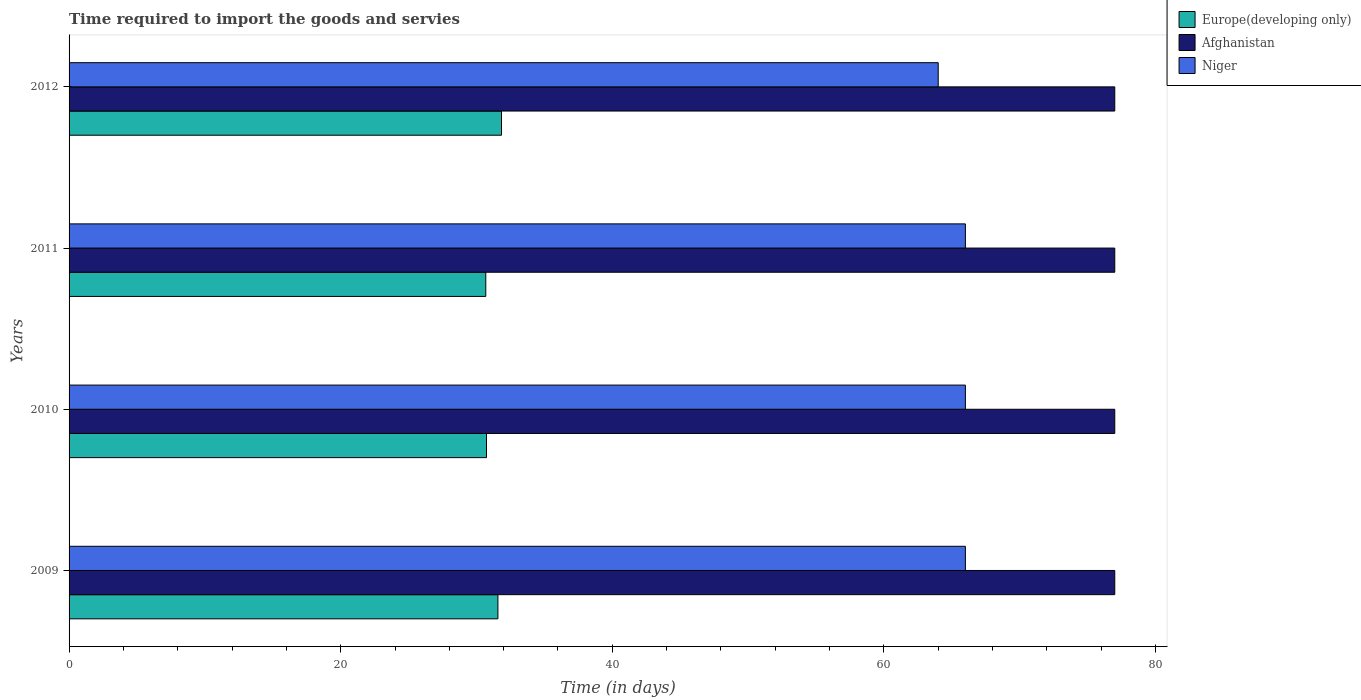How many different coloured bars are there?
Your response must be concise. 3. How many groups of bars are there?
Offer a terse response. 4. Are the number of bars per tick equal to the number of legend labels?
Provide a succinct answer. Yes. Are the number of bars on each tick of the Y-axis equal?
Provide a succinct answer. Yes. How many bars are there on the 4th tick from the top?
Your answer should be compact. 3. What is the label of the 3rd group of bars from the top?
Offer a very short reply. 2010. What is the number of days required to import the goods and services in Europe(developing only) in 2010?
Provide a short and direct response. 30.74. Across all years, what is the maximum number of days required to import the goods and services in Afghanistan?
Provide a succinct answer. 77. Across all years, what is the minimum number of days required to import the goods and services in Niger?
Your answer should be very brief. 64. In which year was the number of days required to import the goods and services in Niger minimum?
Provide a succinct answer. 2012. What is the total number of days required to import the goods and services in Niger in the graph?
Make the answer very short. 262. What is the difference between the number of days required to import the goods and services in Europe(developing only) in 2009 and that in 2011?
Give a very brief answer. 0.89. What is the difference between the number of days required to import the goods and services in Europe(developing only) in 2010 and the number of days required to import the goods and services in Niger in 2011?
Give a very brief answer. -35.26. What is the average number of days required to import the goods and services in Afghanistan per year?
Provide a succinct answer. 77. In the year 2010, what is the difference between the number of days required to import the goods and services in Europe(developing only) and number of days required to import the goods and services in Niger?
Your response must be concise. -35.26. In how many years, is the number of days required to import the goods and services in Europe(developing only) greater than 48 days?
Ensure brevity in your answer.  0. What is the ratio of the number of days required to import the goods and services in Afghanistan in 2010 to that in 2012?
Your answer should be very brief. 1. What is the difference between the highest and the second highest number of days required to import the goods and services in Afghanistan?
Your response must be concise. 0. What is the difference between the highest and the lowest number of days required to import the goods and services in Europe(developing only)?
Your answer should be compact. 1.16. What does the 2nd bar from the top in 2012 represents?
Ensure brevity in your answer.  Afghanistan. What does the 3rd bar from the bottom in 2011 represents?
Provide a short and direct response. Niger. Is it the case that in every year, the sum of the number of days required to import the goods and services in Afghanistan and number of days required to import the goods and services in Niger is greater than the number of days required to import the goods and services in Europe(developing only)?
Ensure brevity in your answer.  Yes. Are all the bars in the graph horizontal?
Offer a terse response. Yes. What is the difference between two consecutive major ticks on the X-axis?
Keep it short and to the point. 20. Where does the legend appear in the graph?
Provide a succinct answer. Top right. How many legend labels are there?
Provide a succinct answer. 3. How are the legend labels stacked?
Ensure brevity in your answer.  Vertical. What is the title of the graph?
Provide a succinct answer. Time required to import the goods and servies. Does "Sub-Saharan Africa (developing only)" appear as one of the legend labels in the graph?
Offer a terse response. No. What is the label or title of the X-axis?
Make the answer very short. Time (in days). What is the label or title of the Y-axis?
Offer a terse response. Years. What is the Time (in days) in Europe(developing only) in 2009?
Make the answer very short. 31.58. What is the Time (in days) of Niger in 2009?
Your answer should be very brief. 66. What is the Time (in days) of Europe(developing only) in 2010?
Keep it short and to the point. 30.74. What is the Time (in days) of Afghanistan in 2010?
Offer a terse response. 77. What is the Time (in days) of Europe(developing only) in 2011?
Your answer should be very brief. 30.68. What is the Time (in days) of Afghanistan in 2011?
Give a very brief answer. 77. What is the Time (in days) in Europe(developing only) in 2012?
Offer a terse response. 31.84. What is the Time (in days) in Niger in 2012?
Offer a terse response. 64. Across all years, what is the maximum Time (in days) in Europe(developing only)?
Provide a succinct answer. 31.84. Across all years, what is the maximum Time (in days) of Afghanistan?
Your answer should be compact. 77. Across all years, what is the maximum Time (in days) in Niger?
Provide a succinct answer. 66. Across all years, what is the minimum Time (in days) in Europe(developing only)?
Ensure brevity in your answer.  30.68. Across all years, what is the minimum Time (in days) in Afghanistan?
Ensure brevity in your answer.  77. What is the total Time (in days) in Europe(developing only) in the graph?
Provide a succinct answer. 124.84. What is the total Time (in days) in Afghanistan in the graph?
Offer a terse response. 308. What is the total Time (in days) of Niger in the graph?
Ensure brevity in your answer.  262. What is the difference between the Time (in days) in Europe(developing only) in 2009 and that in 2010?
Make the answer very short. 0.84. What is the difference between the Time (in days) of Afghanistan in 2009 and that in 2010?
Ensure brevity in your answer.  0. What is the difference between the Time (in days) of Europe(developing only) in 2009 and that in 2011?
Provide a succinct answer. 0.89. What is the difference between the Time (in days) in Niger in 2009 and that in 2011?
Keep it short and to the point. 0. What is the difference between the Time (in days) of Europe(developing only) in 2009 and that in 2012?
Make the answer very short. -0.26. What is the difference between the Time (in days) in Afghanistan in 2009 and that in 2012?
Provide a short and direct response. 0. What is the difference between the Time (in days) in Niger in 2009 and that in 2012?
Your answer should be compact. 2. What is the difference between the Time (in days) of Europe(developing only) in 2010 and that in 2011?
Ensure brevity in your answer.  0.05. What is the difference between the Time (in days) of Afghanistan in 2010 and that in 2011?
Give a very brief answer. 0. What is the difference between the Time (in days) in Niger in 2010 and that in 2011?
Your response must be concise. 0. What is the difference between the Time (in days) in Europe(developing only) in 2010 and that in 2012?
Ensure brevity in your answer.  -1.11. What is the difference between the Time (in days) of Niger in 2010 and that in 2012?
Keep it short and to the point. 2. What is the difference between the Time (in days) of Europe(developing only) in 2011 and that in 2012?
Provide a short and direct response. -1.16. What is the difference between the Time (in days) in Afghanistan in 2011 and that in 2012?
Your response must be concise. 0. What is the difference between the Time (in days) of Niger in 2011 and that in 2012?
Make the answer very short. 2. What is the difference between the Time (in days) in Europe(developing only) in 2009 and the Time (in days) in Afghanistan in 2010?
Offer a terse response. -45.42. What is the difference between the Time (in days) in Europe(developing only) in 2009 and the Time (in days) in Niger in 2010?
Keep it short and to the point. -34.42. What is the difference between the Time (in days) of Europe(developing only) in 2009 and the Time (in days) of Afghanistan in 2011?
Offer a terse response. -45.42. What is the difference between the Time (in days) of Europe(developing only) in 2009 and the Time (in days) of Niger in 2011?
Ensure brevity in your answer.  -34.42. What is the difference between the Time (in days) of Europe(developing only) in 2009 and the Time (in days) of Afghanistan in 2012?
Provide a short and direct response. -45.42. What is the difference between the Time (in days) of Europe(developing only) in 2009 and the Time (in days) of Niger in 2012?
Your response must be concise. -32.42. What is the difference between the Time (in days) of Afghanistan in 2009 and the Time (in days) of Niger in 2012?
Your response must be concise. 13. What is the difference between the Time (in days) in Europe(developing only) in 2010 and the Time (in days) in Afghanistan in 2011?
Make the answer very short. -46.26. What is the difference between the Time (in days) of Europe(developing only) in 2010 and the Time (in days) of Niger in 2011?
Your response must be concise. -35.26. What is the difference between the Time (in days) in Afghanistan in 2010 and the Time (in days) in Niger in 2011?
Ensure brevity in your answer.  11. What is the difference between the Time (in days) of Europe(developing only) in 2010 and the Time (in days) of Afghanistan in 2012?
Ensure brevity in your answer.  -46.26. What is the difference between the Time (in days) of Europe(developing only) in 2010 and the Time (in days) of Niger in 2012?
Provide a short and direct response. -33.26. What is the difference between the Time (in days) in Afghanistan in 2010 and the Time (in days) in Niger in 2012?
Offer a terse response. 13. What is the difference between the Time (in days) in Europe(developing only) in 2011 and the Time (in days) in Afghanistan in 2012?
Give a very brief answer. -46.32. What is the difference between the Time (in days) in Europe(developing only) in 2011 and the Time (in days) in Niger in 2012?
Provide a short and direct response. -33.32. What is the difference between the Time (in days) in Afghanistan in 2011 and the Time (in days) in Niger in 2012?
Provide a succinct answer. 13. What is the average Time (in days) in Europe(developing only) per year?
Your answer should be compact. 31.21. What is the average Time (in days) in Afghanistan per year?
Keep it short and to the point. 77. What is the average Time (in days) of Niger per year?
Make the answer very short. 65.5. In the year 2009, what is the difference between the Time (in days) of Europe(developing only) and Time (in days) of Afghanistan?
Offer a terse response. -45.42. In the year 2009, what is the difference between the Time (in days) of Europe(developing only) and Time (in days) of Niger?
Offer a very short reply. -34.42. In the year 2009, what is the difference between the Time (in days) of Afghanistan and Time (in days) of Niger?
Offer a terse response. 11. In the year 2010, what is the difference between the Time (in days) of Europe(developing only) and Time (in days) of Afghanistan?
Offer a terse response. -46.26. In the year 2010, what is the difference between the Time (in days) in Europe(developing only) and Time (in days) in Niger?
Offer a very short reply. -35.26. In the year 2011, what is the difference between the Time (in days) of Europe(developing only) and Time (in days) of Afghanistan?
Provide a succinct answer. -46.32. In the year 2011, what is the difference between the Time (in days) in Europe(developing only) and Time (in days) in Niger?
Provide a short and direct response. -35.32. In the year 2011, what is the difference between the Time (in days) of Afghanistan and Time (in days) of Niger?
Provide a succinct answer. 11. In the year 2012, what is the difference between the Time (in days) of Europe(developing only) and Time (in days) of Afghanistan?
Offer a terse response. -45.16. In the year 2012, what is the difference between the Time (in days) in Europe(developing only) and Time (in days) in Niger?
Your response must be concise. -32.16. In the year 2012, what is the difference between the Time (in days) in Afghanistan and Time (in days) in Niger?
Provide a short and direct response. 13. What is the ratio of the Time (in days) of Europe(developing only) in 2009 to that in 2010?
Keep it short and to the point. 1.03. What is the ratio of the Time (in days) of Niger in 2009 to that in 2010?
Provide a succinct answer. 1. What is the ratio of the Time (in days) of Europe(developing only) in 2009 to that in 2011?
Your answer should be compact. 1.03. What is the ratio of the Time (in days) in Afghanistan in 2009 to that in 2011?
Give a very brief answer. 1. What is the ratio of the Time (in days) of Niger in 2009 to that in 2011?
Offer a very short reply. 1. What is the ratio of the Time (in days) of Europe(developing only) in 2009 to that in 2012?
Your response must be concise. 0.99. What is the ratio of the Time (in days) in Niger in 2009 to that in 2012?
Keep it short and to the point. 1.03. What is the ratio of the Time (in days) of Niger in 2010 to that in 2011?
Ensure brevity in your answer.  1. What is the ratio of the Time (in days) of Europe(developing only) in 2010 to that in 2012?
Provide a succinct answer. 0.97. What is the ratio of the Time (in days) of Niger in 2010 to that in 2012?
Ensure brevity in your answer.  1.03. What is the ratio of the Time (in days) of Europe(developing only) in 2011 to that in 2012?
Keep it short and to the point. 0.96. What is the ratio of the Time (in days) in Niger in 2011 to that in 2012?
Provide a short and direct response. 1.03. What is the difference between the highest and the second highest Time (in days) of Europe(developing only)?
Provide a short and direct response. 0.26. What is the difference between the highest and the second highest Time (in days) in Niger?
Your response must be concise. 0. What is the difference between the highest and the lowest Time (in days) in Europe(developing only)?
Your answer should be compact. 1.16. What is the difference between the highest and the lowest Time (in days) in Afghanistan?
Your answer should be very brief. 0. What is the difference between the highest and the lowest Time (in days) in Niger?
Your answer should be compact. 2. 